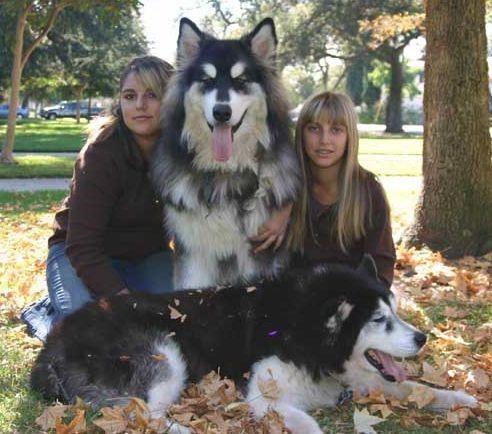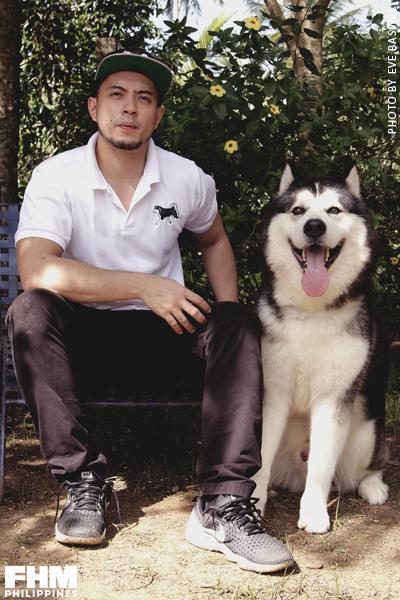The first image is the image on the left, the second image is the image on the right. Given the left and right images, does the statement "Three people are sitting and posing for a portrait with a Malamute." hold true? Answer yes or no. Yes. The first image is the image on the left, the second image is the image on the right. Considering the images on both sides, is "The left image features at least two people and at least one open-mouthed dog, and they are posed with three of their heads in a row." valid? Answer yes or no. Yes. 